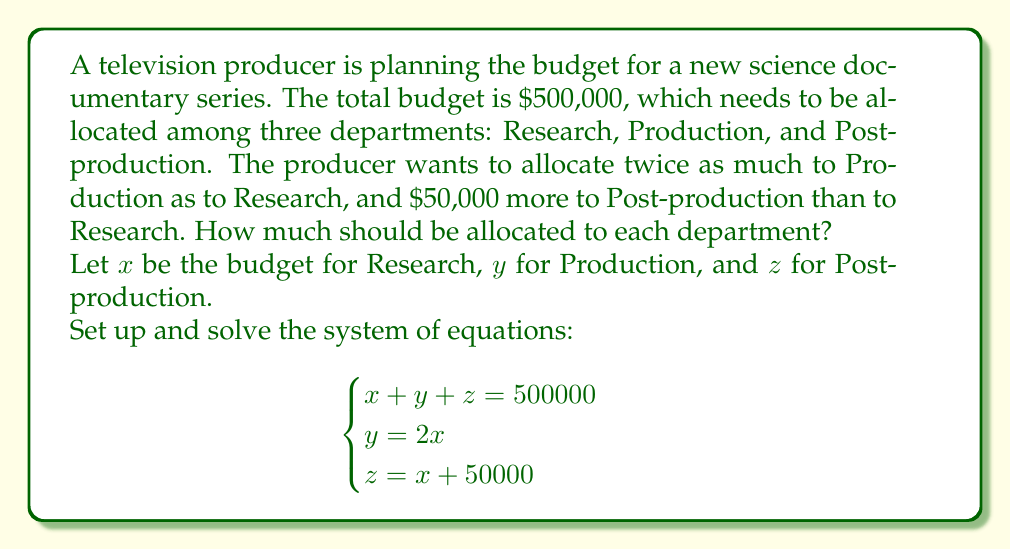Show me your answer to this math problem. Let's solve this system of equations step by step:

1) We have three equations:
   $$\begin{cases}
   x + y + z = 500000 \quad (1)\\
   y = 2x \quad (2)\\
   z = x + 50000 \quad (3)
   \end{cases}$$

2) Substitute equation (2) into equation (1):
   $x + 2x + z = 500000$
   $3x + z = 500000 \quad (4)$

3) Substitute equation (3) into equation (4):
   $3x + (x + 50000) = 500000$
   $4x + 50000 = 500000$

4) Solve for $x$:
   $4x = 450000$
   $x = 112500$

5) Now that we know $x$, we can find $y$ and $z$:
   $y = 2x = 2(112500) = 225000$
   $z = x + 50000 = 112500 + 50000 = 162500$

6) Verify the solution:
   $112500 + 225000 + 162500 = 500000$

Therefore, the budget allocation should be:
Research (x): $112,500
Production (y): $225,000
Post-production (z): $162,500
Answer: Research: $112,500; Production: $225,000; Post-production: $162,500 